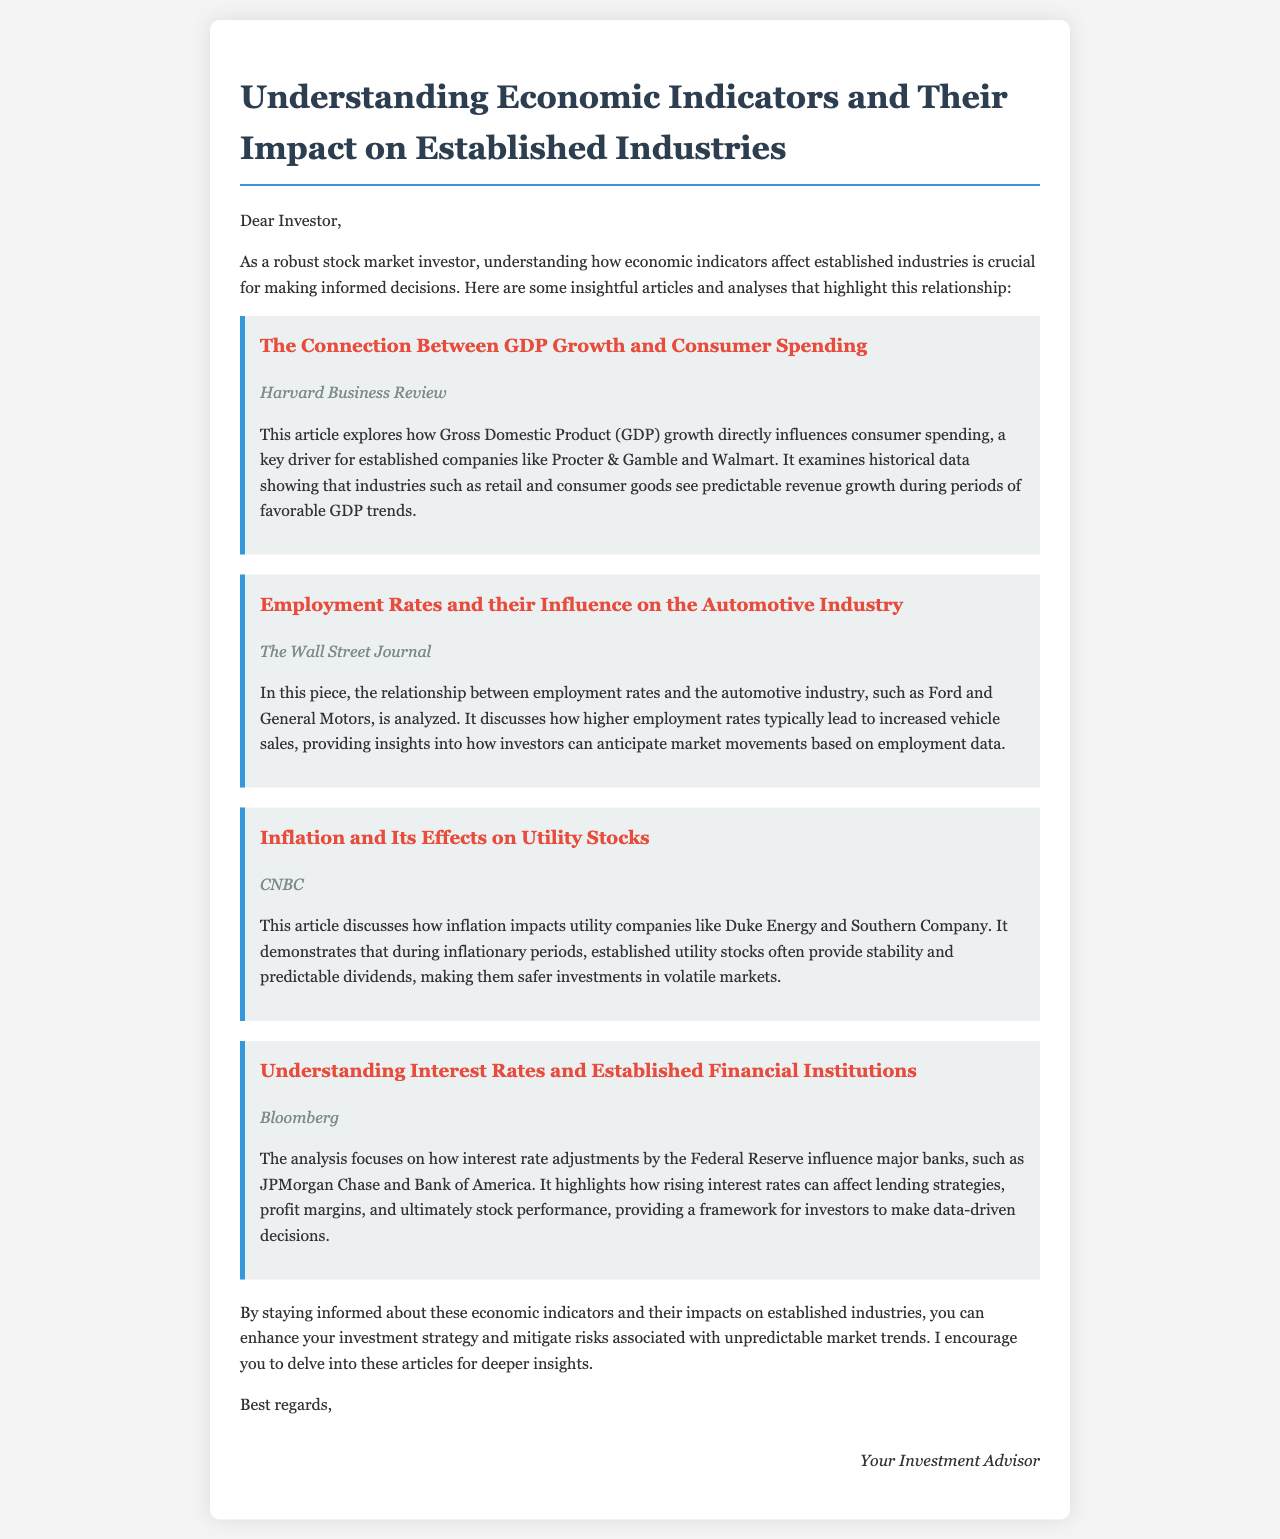What is the title of the first article? The title of the first article is provided in the document under the article section.
Answer: The Connection Between GDP Growth and Consumer Spending Who is the source of the second article? The source of the second article is mentioned directly under the title in the document.
Answer: The Wall Street Journal Which established companies are discussed in relation to inflation? The document explicitly states the companies affected by inflation in the context of utility stocks.
Answer: Duke Energy and Southern Company What economic indicator is analyzed in the article regarding the automotive industry? The economic indicator discussed in the automotive industry article is mentioned at the beginning of the explanation.
Answer: Employment Rates How do higher employment rates affect vehicle sales? The document provides a direct correlation between employment rates and their impact on vehicle sales in the automotive industry.
Answer: Increased vehicle sales What industry does the last article focus on? The industry focused on in the last article is clearly stated in the title of the article within the document.
Answer: Financial Institutions How can understanding economic indicators benefit investors? The document explains the benefits of understanding economic indicators and their effects on investment strategy.
Answer: Enhance investment strategy What is the recommendation given to investors at the end of the document? The recommendation to investors is found in the concluding lines and highlights an action to take based on the content.
Answer: Delve into these articles for deeper insights 